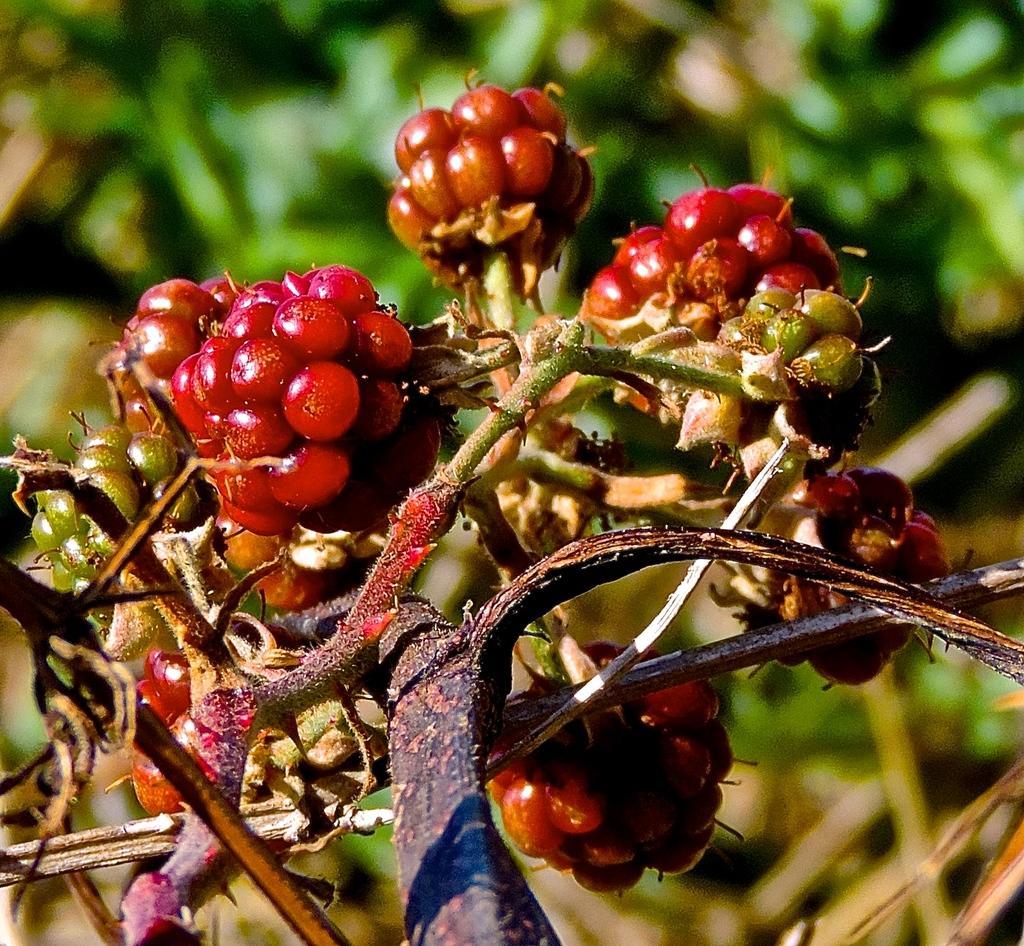Please provide a concise description of this image. In this image we can see some berries on the stem of a plant. 